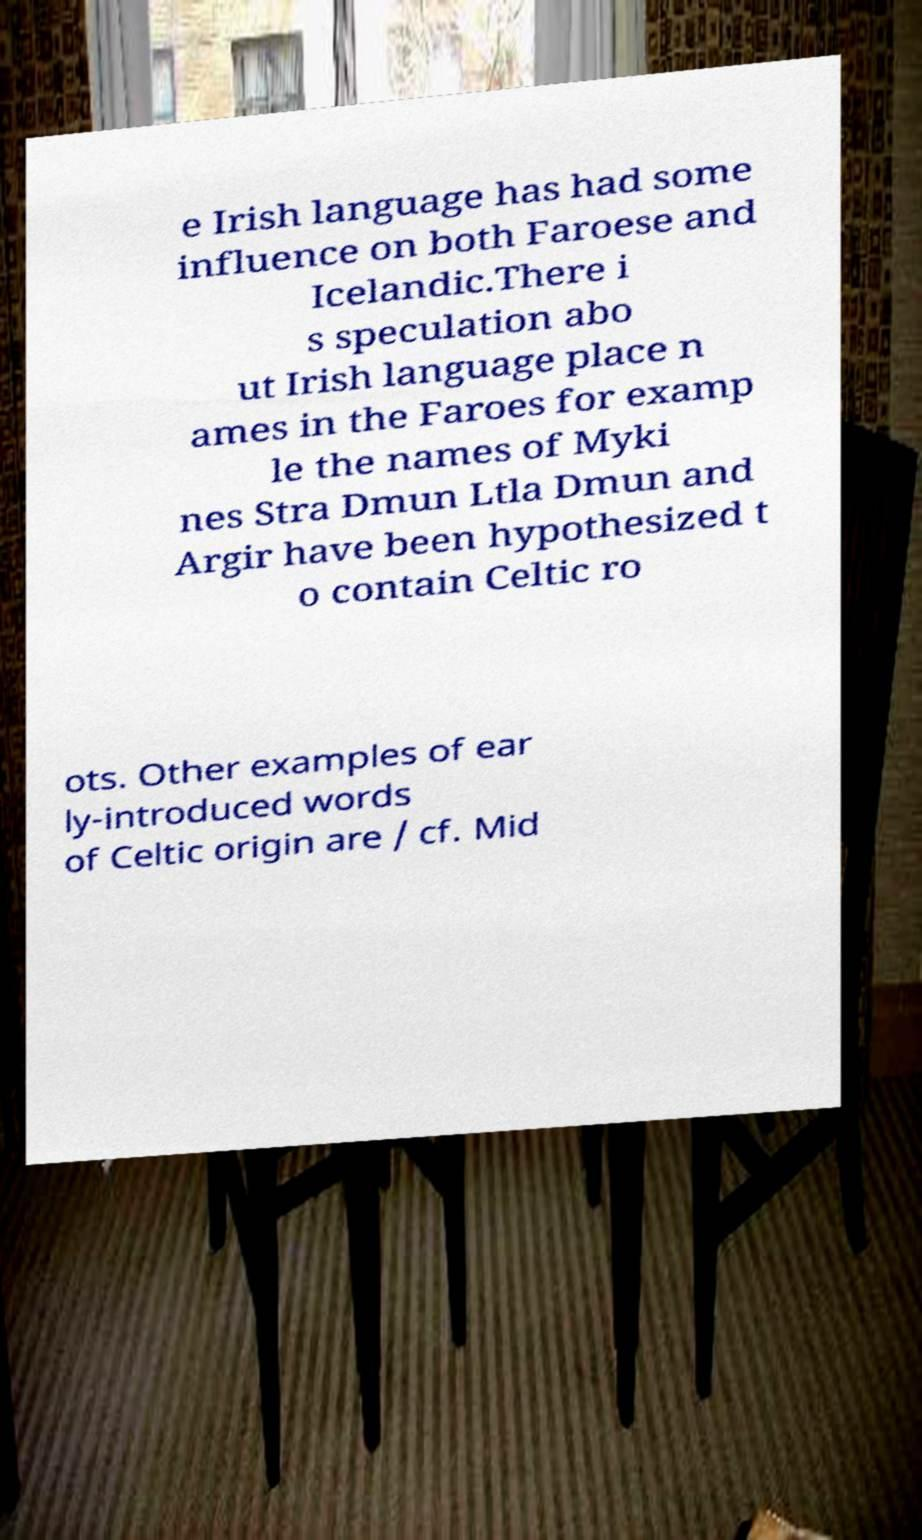I need the written content from this picture converted into text. Can you do that? e Irish language has had some influence on both Faroese and Icelandic.There i s speculation abo ut Irish language place n ames in the Faroes for examp le the names of Myki nes Stra Dmun Ltla Dmun and Argir have been hypothesized t o contain Celtic ro ots. Other examples of ear ly-introduced words of Celtic origin are / cf. Mid 